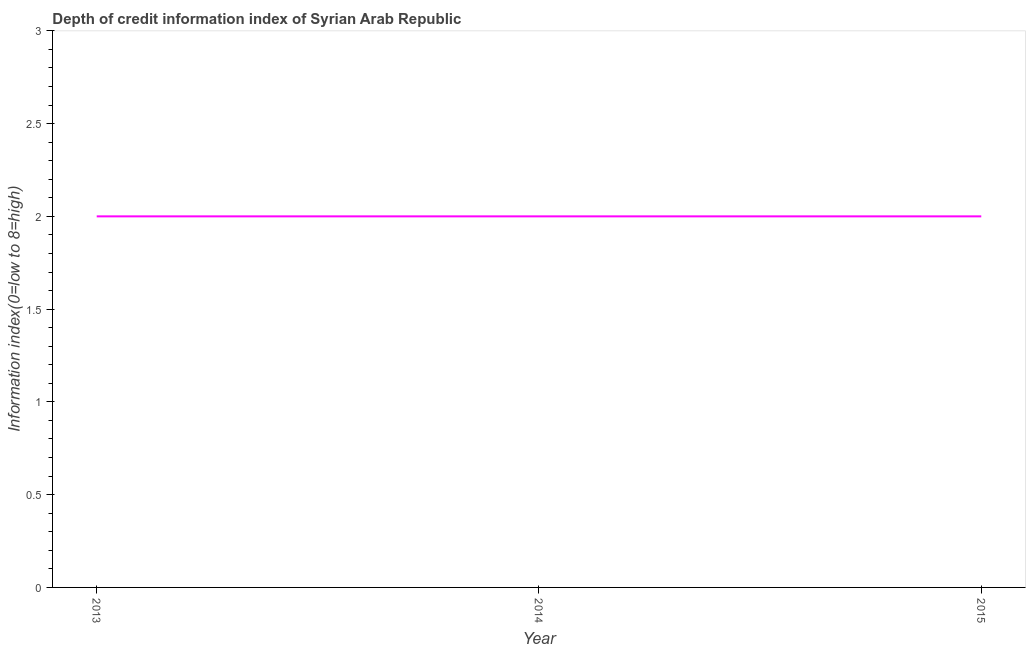What is the depth of credit information index in 2013?
Offer a terse response. 2. Across all years, what is the maximum depth of credit information index?
Your answer should be very brief. 2. Across all years, what is the minimum depth of credit information index?
Ensure brevity in your answer.  2. In which year was the depth of credit information index maximum?
Your response must be concise. 2013. What is the sum of the depth of credit information index?
Offer a very short reply. 6. What is the difference between the depth of credit information index in 2013 and 2014?
Ensure brevity in your answer.  0. What is the ratio of the depth of credit information index in 2014 to that in 2015?
Make the answer very short. 1. Is the depth of credit information index in 2013 less than that in 2015?
Ensure brevity in your answer.  No. What is the difference between the highest and the second highest depth of credit information index?
Ensure brevity in your answer.  0. Is the sum of the depth of credit information index in 2013 and 2014 greater than the maximum depth of credit information index across all years?
Your answer should be compact. Yes. In how many years, is the depth of credit information index greater than the average depth of credit information index taken over all years?
Provide a succinct answer. 0. What is the difference between two consecutive major ticks on the Y-axis?
Offer a terse response. 0.5. Are the values on the major ticks of Y-axis written in scientific E-notation?
Keep it short and to the point. No. Does the graph contain grids?
Offer a very short reply. No. What is the title of the graph?
Provide a succinct answer. Depth of credit information index of Syrian Arab Republic. What is the label or title of the X-axis?
Keep it short and to the point. Year. What is the label or title of the Y-axis?
Make the answer very short. Information index(0=low to 8=high). What is the Information index(0=low to 8=high) in 2013?
Offer a very short reply. 2. What is the Information index(0=low to 8=high) of 2015?
Your answer should be compact. 2. What is the difference between the Information index(0=low to 8=high) in 2013 and 2014?
Ensure brevity in your answer.  0. What is the difference between the Information index(0=low to 8=high) in 2014 and 2015?
Make the answer very short. 0. What is the ratio of the Information index(0=low to 8=high) in 2013 to that in 2014?
Provide a succinct answer. 1. What is the ratio of the Information index(0=low to 8=high) in 2013 to that in 2015?
Offer a terse response. 1. 